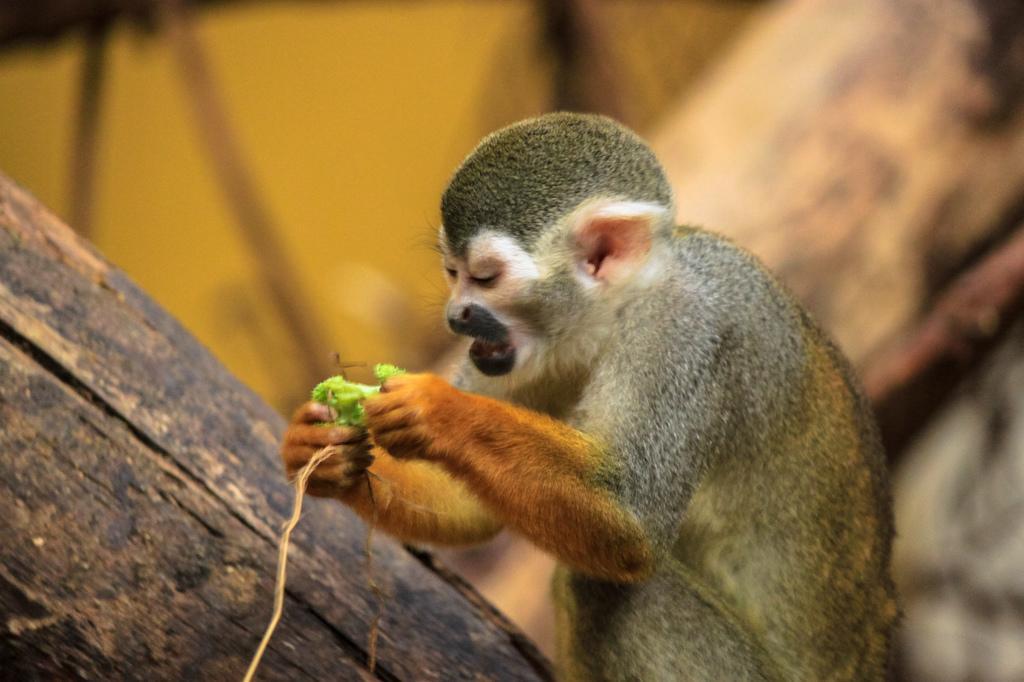Could you give a brief overview of what you see in this image? This picture might be taken from forest. in this image, in the middle, we can see monkey holding something in its hand. on the left side, there is a wood. In the background, we can see yellow color. 